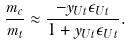<formula> <loc_0><loc_0><loc_500><loc_500>\frac { m _ { c } } { m _ { t } } \approx \frac { - y _ { U t } \epsilon _ { U t } } { 1 + y _ { U t } \epsilon _ { U t } } .</formula> 